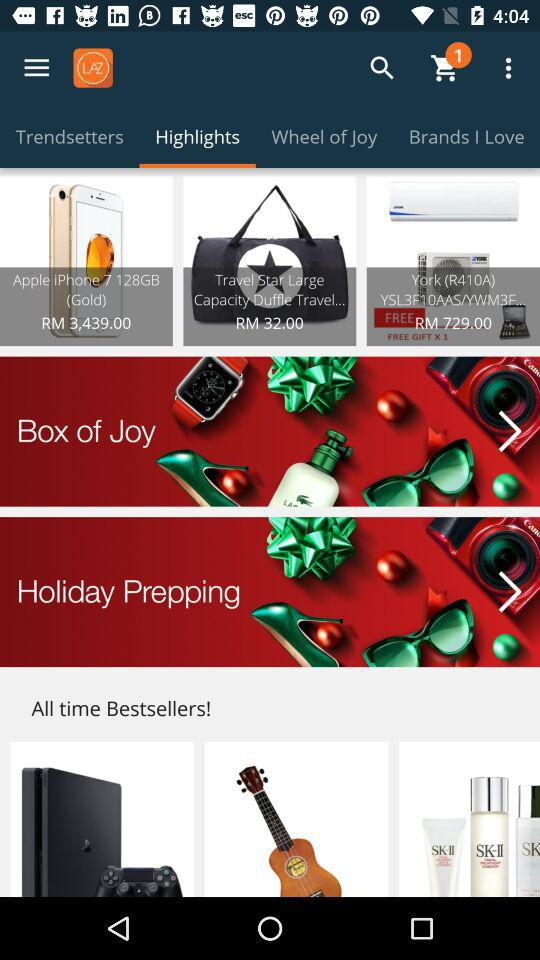How many items are in the 'All time Bestsellers!' section?
Answer the question using a single word or phrase. 3 